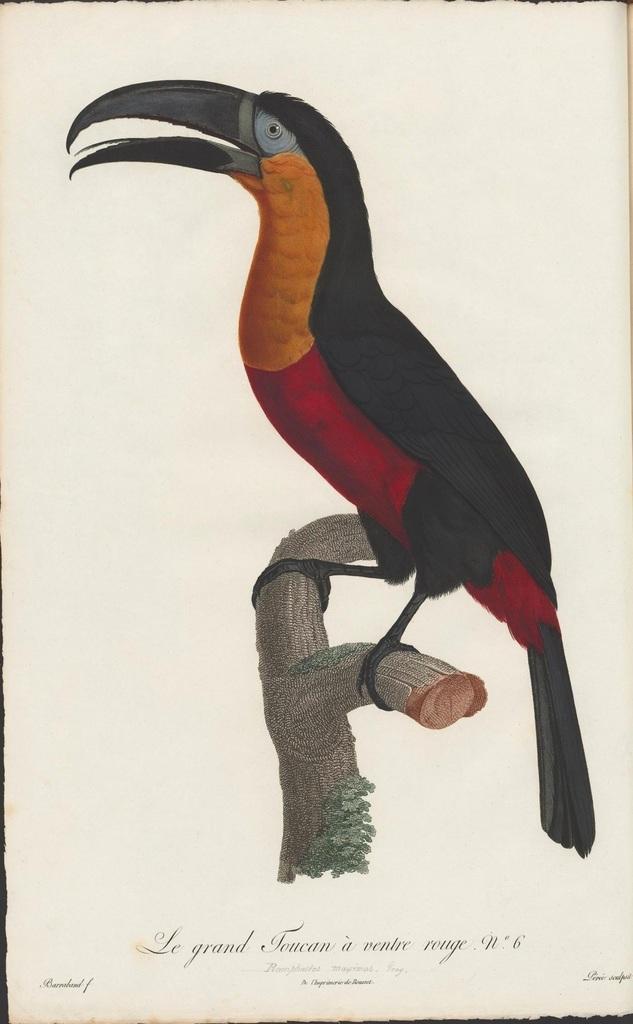In one or two sentences, can you explain what this image depicts? In this picture I can see a painting of a bird and tree stem. 